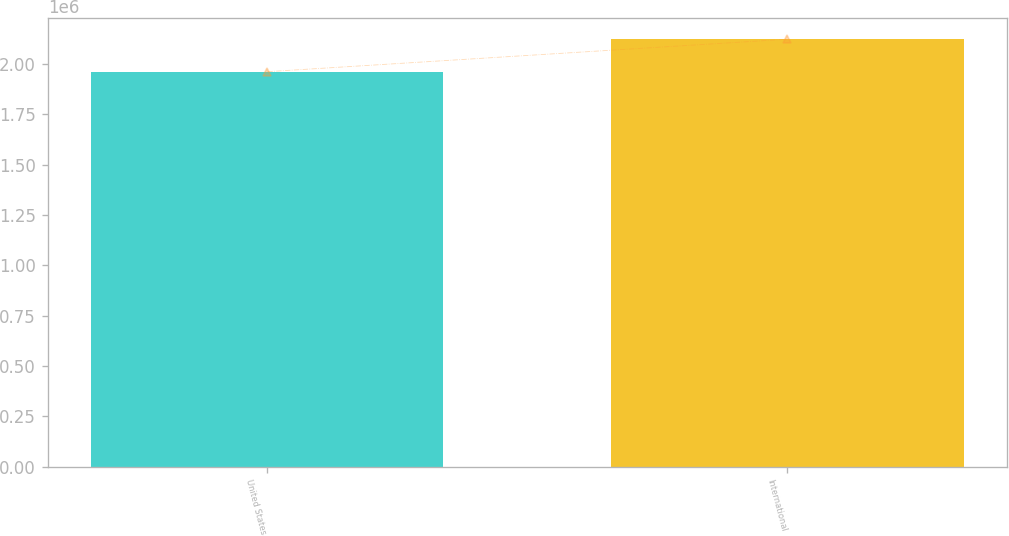<chart> <loc_0><loc_0><loc_500><loc_500><bar_chart><fcel>United States<fcel>International<nl><fcel>1.96048e+06<fcel>2.12168e+06<nl></chart> 